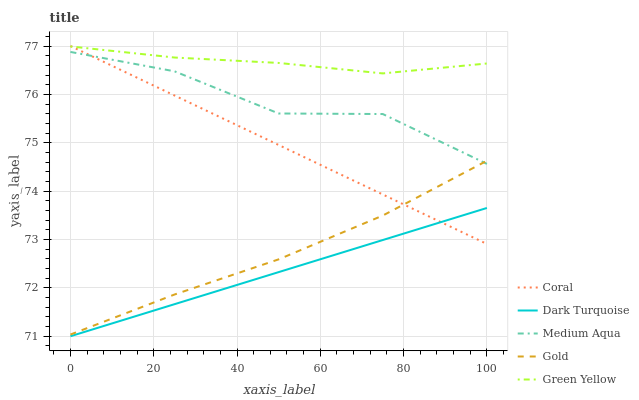Does Dark Turquoise have the minimum area under the curve?
Answer yes or no. Yes. Does Green Yellow have the maximum area under the curve?
Answer yes or no. Yes. Does Coral have the minimum area under the curve?
Answer yes or no. No. Does Coral have the maximum area under the curve?
Answer yes or no. No. Is Dark Turquoise the smoothest?
Answer yes or no. Yes. Is Medium Aqua the roughest?
Answer yes or no. Yes. Is Coral the smoothest?
Answer yes or no. No. Is Coral the roughest?
Answer yes or no. No. Does Dark Turquoise have the lowest value?
Answer yes or no. Yes. Does Coral have the lowest value?
Answer yes or no. No. Does Coral have the highest value?
Answer yes or no. Yes. Does Green Yellow have the highest value?
Answer yes or no. No. Is Dark Turquoise less than Green Yellow?
Answer yes or no. Yes. Is Green Yellow greater than Gold?
Answer yes or no. Yes. Does Coral intersect Medium Aqua?
Answer yes or no. Yes. Is Coral less than Medium Aqua?
Answer yes or no. No. Is Coral greater than Medium Aqua?
Answer yes or no. No. Does Dark Turquoise intersect Green Yellow?
Answer yes or no. No. 